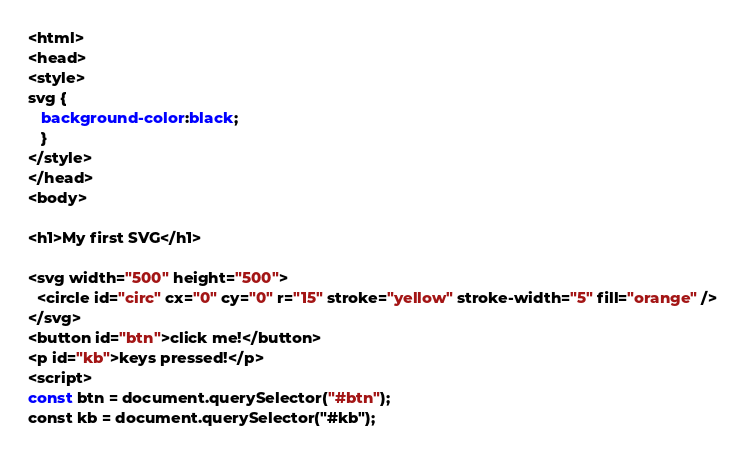Convert code to text. <code><loc_0><loc_0><loc_500><loc_500><_HTML_><html>
<head>
<style>
svg {
   background-color:black;
   }
</style>
</head>
<body>

<h1>My first SVG</h1>

<svg width="500" height="500">
  <circle id="circ" cx="0" cy="0" r="15" stroke="yellow" stroke-width="5" fill="orange" />
</svg>
<button id="btn">click me!</button>
<p id="kb">keys pressed!</p>
<script>
const btn = document.querySelector("#btn");
const kb = document.querySelector("#kb");</code> 